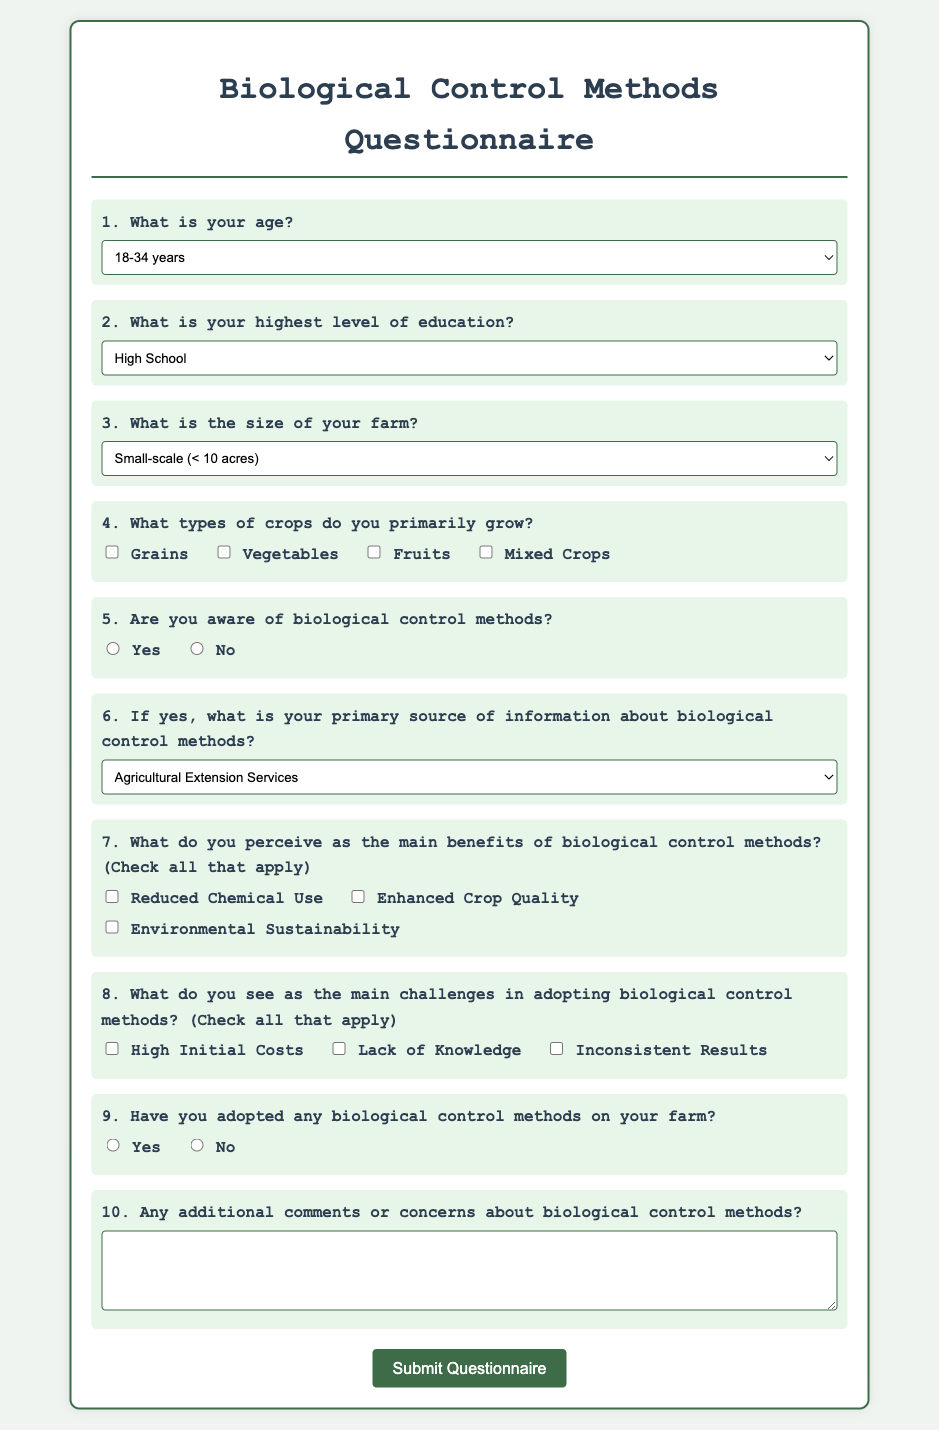What is the title of the questionnaire? The title is presented prominently at the top of the document, identifying the subject of the questionnaire.
Answer: Biological Control Methods Questionnaire What age range is included in the questionnaire options? The age options include specific ranges listed in the first question.
Answer: 18-34 years, 35-50 years, 50+ years What is the highest level of education option listed? The education options include different levels, with the highest level specified.
Answer: Higher than Bachelor's What is the smallest farm size category? The farm size options categorize it by scale, including specific acreages.
Answer: Small-scale (< 10 acres) Which option represents the primary source of information about biological control methods? The options for the source of information indicate a reference to Agricultural Extension Services among others.
Answer: Agricultural Extension Services What are two perceived benefits of biological control methods? The benefits are listed as checkboxes and can be selected among other options.
Answer: Reduced Chemical Use, Environmental Sustainability What do farmers perceive as a main challenge in adopting biological control methods? The challenges are outlined, including specific concerns that farmers might have.
Answer: High Initial Costs Have any of the respondents adopted biological control methods? The question asks for a simple yes or no answer from respondents about their adoption.
Answer: Yes or No What is the last question in the questionnaire? The structure of the questionnaire concludes with an open-ended question for additional comments.
Answer: Any additional comments or concerns about biological control methods? 